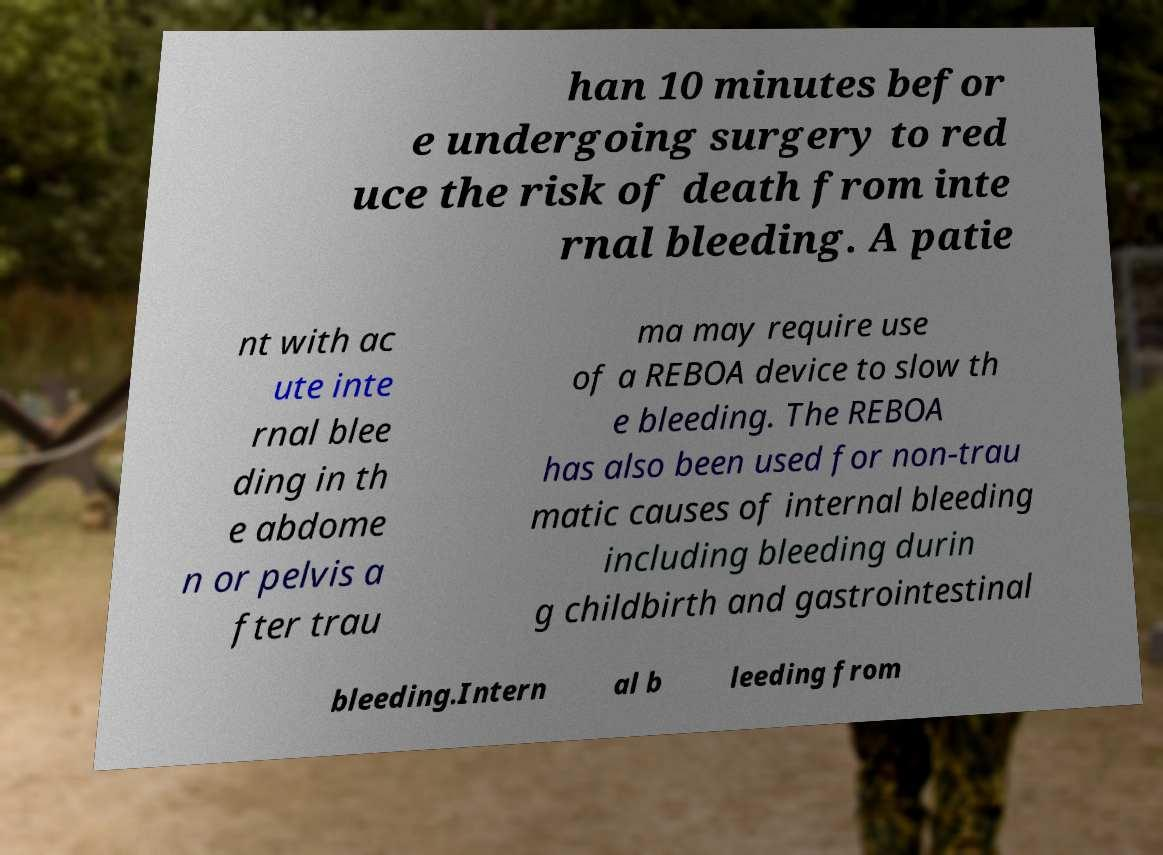Can you accurately transcribe the text from the provided image for me? han 10 minutes befor e undergoing surgery to red uce the risk of death from inte rnal bleeding. A patie nt with ac ute inte rnal blee ding in th e abdome n or pelvis a fter trau ma may require use of a REBOA device to slow th e bleeding. The REBOA has also been used for non-trau matic causes of internal bleeding including bleeding durin g childbirth and gastrointestinal bleeding.Intern al b leeding from 